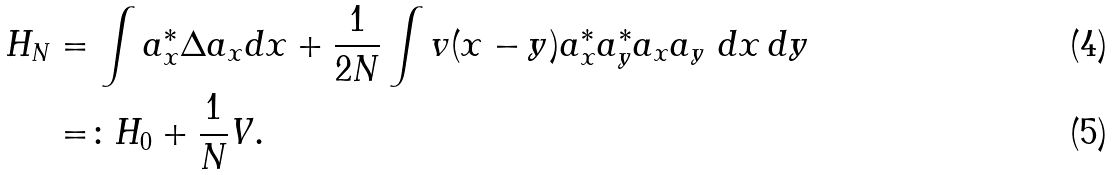<formula> <loc_0><loc_0><loc_500><loc_500>H _ { N } & = \int a _ { x } ^ { * } \Delta a _ { x } d x + \frac { 1 } { 2 N } \int v ( x - y ) a _ { x } ^ { * } a _ { y } ^ { * } a _ { x } a _ { y } \ d x \, d y \\ & = \colon H _ { 0 } + \frac { 1 } { N } V .</formula> 